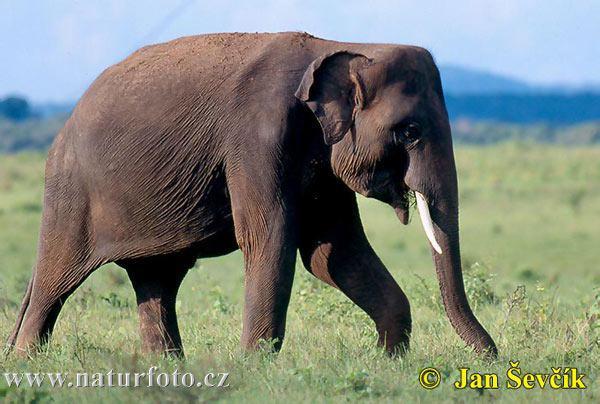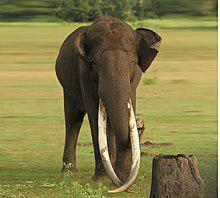The first image is the image on the left, the second image is the image on the right. Given the left and right images, does the statement "There are two elephants in total." hold true? Answer yes or no. Yes. 